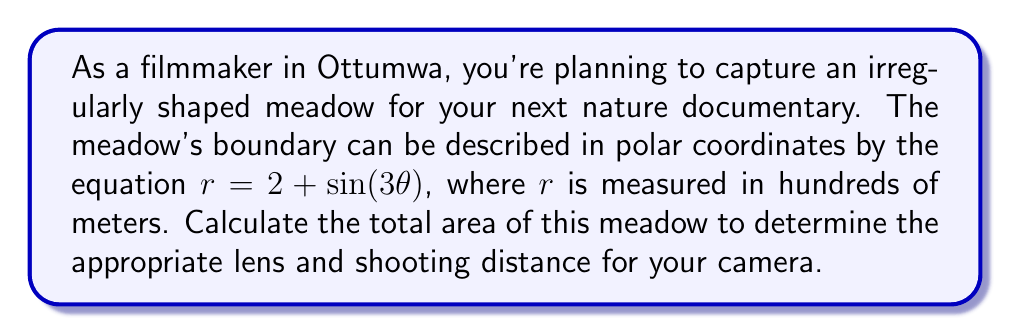Give your solution to this math problem. To find the area of this irregularly shaped meadow, we'll use polar integration. The formula for the area of a region in polar coordinates is:

$$A = \frac{1}{2} \int_a^b r^2(\theta) d\theta$$

Where $r(\theta)$ is the polar equation of the boundary, and $a$ and $b$ are the starting and ending angles.

For our meadow, $r(\theta) = 2 + \sin(3\theta)$, and we need to integrate over a full revolution, so $a = 0$ and $b = 2\pi$.

Let's solve this step-by-step:

1) Substitute the given function into the area formula:

   $$A = \frac{1}{2} \int_0^{2\pi} (2 + \sin(3\theta))^2 d\theta$$

2) Expand the squared term:

   $$A = \frac{1}{2} \int_0^{2\pi} (4 + 4\sin(3\theta) + \sin^2(3\theta)) d\theta$$

3) Distribute the integral:

   $$A = \frac{1}{2} \left[\int_0^{2\pi} 4 d\theta + \int_0^{2\pi} 4\sin(3\theta) d\theta + \int_0^{2\pi} \sin^2(3\theta) d\theta\right]$$

4) Solve each integral:
   - $\int_0^{2\pi} 4 d\theta = 4\theta \big|_0^{2\pi} = 8\pi$
   - $\int_0^{2\pi} 4\sin(3\theta) d\theta = -\frac{4}{3}\cos(3\theta) \big|_0^{2\pi} = 0$
   - $\int_0^{2\pi} \sin^2(3\theta) d\theta = \int_0^{2\pi} \frac{1 - \cos(6\theta)}{2} d\theta = \frac{\theta}{2} - \frac{\sin(6\theta)}{12} \big|_0^{2\pi} = \pi$

5) Sum up the results:

   $$A = \frac{1}{2} (8\pi + 0 + \pi) = \frac{9\pi}{2}$$

6) Remember that $r$ was measured in hundreds of meters, so we need to square this to get the actual area:

   $$A = \frac{9\pi}{2} * (100 \text{ m})^2 = 45000\pi \text{ m}^2$$
Answer: The total area of the meadow is $45000\pi$ square meters or approximately 141,371 square meters. 